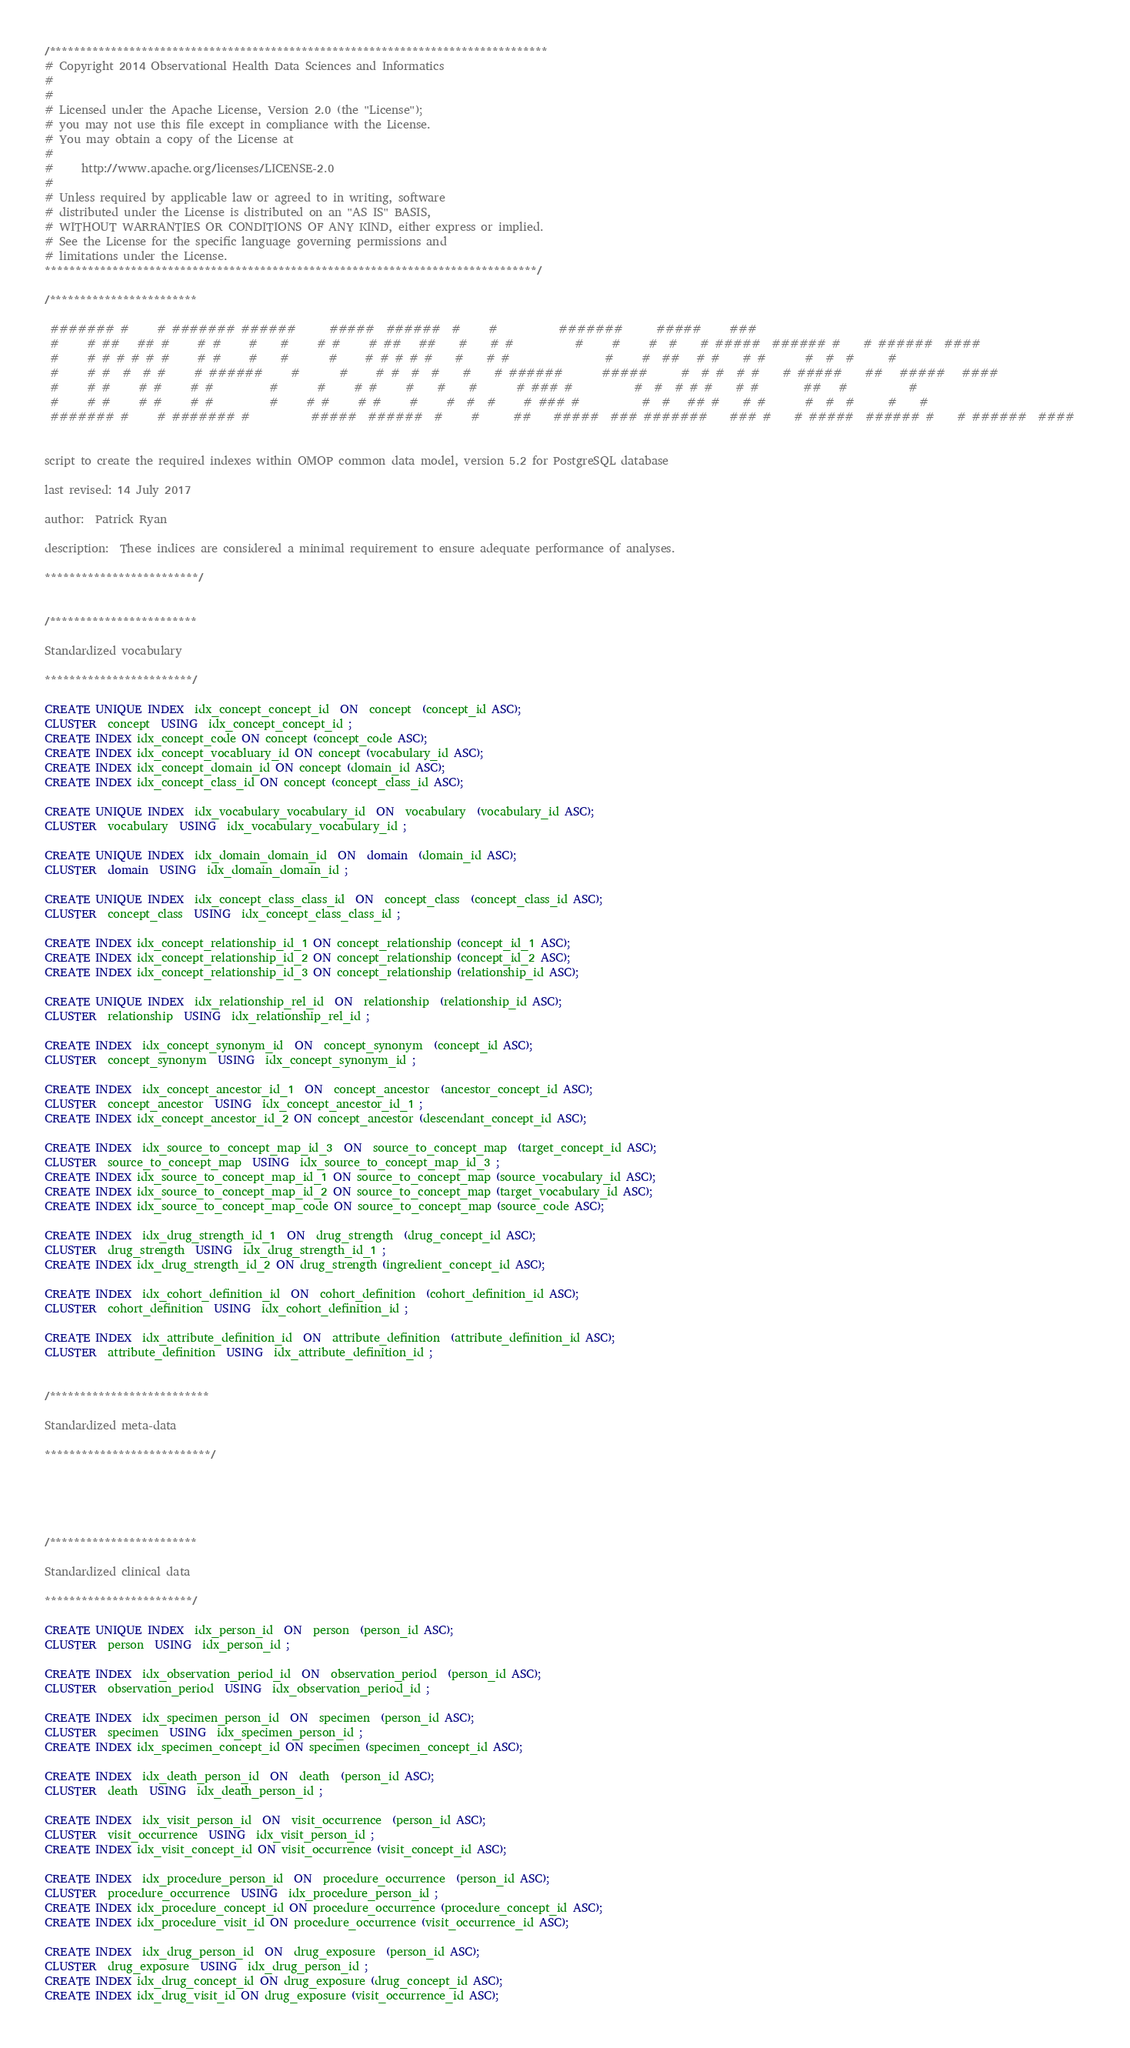Convert code to text. <code><loc_0><loc_0><loc_500><loc_500><_SQL_>/*********************************************************************************
# Copyright 2014 Observational Health Data Sciences and Informatics
#
# 
# Licensed under the Apache License, Version 2.0 (the "License");
# you may not use this file except in compliance with the License.
# You may obtain a copy of the License at
# 
#     http://www.apache.org/licenses/LICENSE-2.0
# 
# Unless required by applicable law or agreed to in writing, software
# distributed under the License is distributed on an "AS IS" BASIS,
# WITHOUT WARRANTIES OR CONDITIONS OF ANY KIND, either express or implied.
# See the License for the specific language governing permissions and
# limitations under the License.
********************************************************************************/

/************************

 ####### #     # ####### ######      #####  ######  #     #           #######      #####     ###                                           
 #     # ##   ## #     # #     #    #     # #     # ##   ##    #    # #           #     #     #  #    # #####  ###### #    # ######  ####  
 #     # # # # # #     # #     #    #       #     # # # # #    #    # #                 #     #  ##   # #    # #       #  #  #      #      
 #     # #  #  # #     # ######     #       #     # #  #  #    #    # ######       #####      #  # #  # #    # #####    ##   #####   ####  
 #     # #     # #     # #          #       #     # #     #    #    #       # ### #           #  #  # # #    # #        ##   #           # 
 #     # #     # #     # #          #     # #     # #     #     #  #  #     # ### #           #  #   ## #    # #       #  #  #      #    # 
 ####### #     # ####### #           #####  ######  #     #      ##    #####  ### #######    ### #    # #####  ###### #    # ######  ####  
                                                                              

script to create the required indexes within OMOP common data model, version 5.2 for PostgreSQL database

last revised: 14 July 2017

author:  Patrick Ryan

description:  These indices are considered a minimal requirement to ensure adequate performance of analyses.

*************************/


/************************

Standardized vocabulary

************************/

CREATE UNIQUE INDEX  idx_concept_concept_id  ON  concept  (concept_id ASC);
CLUSTER  concept  USING  idx_concept_concept_id ;
CREATE INDEX idx_concept_code ON concept (concept_code ASC);
CREATE INDEX idx_concept_vocabluary_id ON concept (vocabulary_id ASC);
CREATE INDEX idx_concept_domain_id ON concept (domain_id ASC);
CREATE INDEX idx_concept_class_id ON concept (concept_class_id ASC);

CREATE UNIQUE INDEX  idx_vocabulary_vocabulary_id  ON  vocabulary  (vocabulary_id ASC);
CLUSTER  vocabulary  USING  idx_vocabulary_vocabulary_id ;

CREATE UNIQUE INDEX  idx_domain_domain_id  ON  domain  (domain_id ASC);
CLUSTER  domain  USING  idx_domain_domain_id ;

CREATE UNIQUE INDEX  idx_concept_class_class_id  ON  concept_class  (concept_class_id ASC);
CLUSTER  concept_class  USING  idx_concept_class_class_id ;

CREATE INDEX idx_concept_relationship_id_1 ON concept_relationship (concept_id_1 ASC); 
CREATE INDEX idx_concept_relationship_id_2 ON concept_relationship (concept_id_2 ASC); 
CREATE INDEX idx_concept_relationship_id_3 ON concept_relationship (relationship_id ASC); 

CREATE UNIQUE INDEX  idx_relationship_rel_id  ON  relationship  (relationship_id ASC);
CLUSTER  relationship  USING  idx_relationship_rel_id ;

CREATE INDEX  idx_concept_synonym_id  ON  concept_synonym  (concept_id ASC);
CLUSTER  concept_synonym  USING  idx_concept_synonym_id ;

CREATE INDEX  idx_concept_ancestor_id_1  ON  concept_ancestor  (ancestor_concept_id ASC);
CLUSTER  concept_ancestor  USING  idx_concept_ancestor_id_1 ;
CREATE INDEX idx_concept_ancestor_id_2 ON concept_ancestor (descendant_concept_id ASC);

CREATE INDEX  idx_source_to_concept_map_id_3  ON  source_to_concept_map  (target_concept_id ASC);
CLUSTER  source_to_concept_map  USING  idx_source_to_concept_map_id_3 ;
CREATE INDEX idx_source_to_concept_map_id_1 ON source_to_concept_map (source_vocabulary_id ASC);
CREATE INDEX idx_source_to_concept_map_id_2 ON source_to_concept_map (target_vocabulary_id ASC);
CREATE INDEX idx_source_to_concept_map_code ON source_to_concept_map (source_code ASC);

CREATE INDEX  idx_drug_strength_id_1  ON  drug_strength  (drug_concept_id ASC);
CLUSTER  drug_strength  USING  idx_drug_strength_id_1 ;
CREATE INDEX idx_drug_strength_id_2 ON drug_strength (ingredient_concept_id ASC);

CREATE INDEX  idx_cohort_definition_id  ON  cohort_definition  (cohort_definition_id ASC);
CLUSTER  cohort_definition  USING  idx_cohort_definition_id ;

CREATE INDEX  idx_attribute_definition_id  ON  attribute_definition  (attribute_definition_id ASC);
CLUSTER  attribute_definition  USING  idx_attribute_definition_id ;


/**************************

Standardized meta-data

***************************/





/************************

Standardized clinical data

************************/

CREATE UNIQUE INDEX  idx_person_id  ON  person  (person_id ASC);
CLUSTER  person  USING  idx_person_id ;

CREATE INDEX  idx_observation_period_id  ON  observation_period  (person_id ASC);
CLUSTER  observation_period  USING  idx_observation_period_id ;

CREATE INDEX  idx_specimen_person_id  ON  specimen  (person_id ASC);
CLUSTER  specimen  USING  idx_specimen_person_id ;
CREATE INDEX idx_specimen_concept_id ON specimen (specimen_concept_id ASC);

CREATE INDEX  idx_death_person_id  ON  death  (person_id ASC);
CLUSTER  death  USING  idx_death_person_id ;

CREATE INDEX  idx_visit_person_id  ON  visit_occurrence  (person_id ASC);
CLUSTER  visit_occurrence  USING  idx_visit_person_id ;
CREATE INDEX idx_visit_concept_id ON visit_occurrence (visit_concept_id ASC);

CREATE INDEX  idx_procedure_person_id  ON  procedure_occurrence  (person_id ASC);
CLUSTER  procedure_occurrence  USING  idx_procedure_person_id ;
CREATE INDEX idx_procedure_concept_id ON procedure_occurrence (procedure_concept_id ASC);
CREATE INDEX idx_procedure_visit_id ON procedure_occurrence (visit_occurrence_id ASC);

CREATE INDEX  idx_drug_person_id  ON  drug_exposure  (person_id ASC);
CLUSTER  drug_exposure  USING  idx_drug_person_id ;
CREATE INDEX idx_drug_concept_id ON drug_exposure (drug_concept_id ASC);
CREATE INDEX idx_drug_visit_id ON drug_exposure (visit_occurrence_id ASC);
</code> 